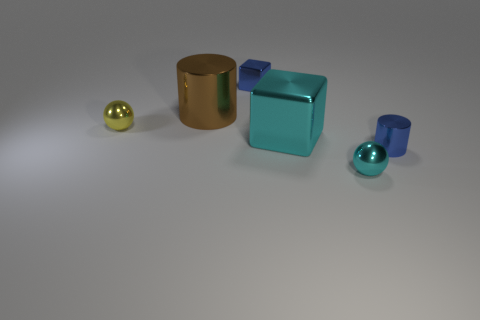Can you describe the textural differences between the objects? Certainly! The objects exhibit various textures; the spheres and the cube have smooth and reflective surfaces, while the cylinder has a slightly matte finish, indicating a less reflective material with a potential slight texture.  Is there any object that stands out from the rest? The large cyan object stands out due to its size, color, and central placement in the composition. Its bold cyan hue contrasts with the otherwise metallic color palette of the scene. 